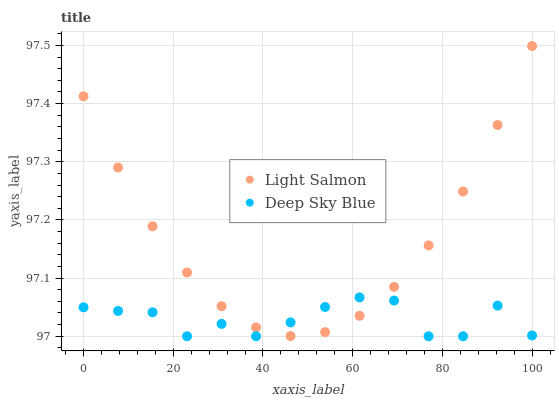Does Deep Sky Blue have the minimum area under the curve?
Answer yes or no. Yes. Does Light Salmon have the maximum area under the curve?
Answer yes or no. Yes. Does Deep Sky Blue have the maximum area under the curve?
Answer yes or no. No. Is Light Salmon the smoothest?
Answer yes or no. Yes. Is Deep Sky Blue the roughest?
Answer yes or no. Yes. Is Deep Sky Blue the smoothest?
Answer yes or no. No. Does Deep Sky Blue have the lowest value?
Answer yes or no. Yes. Does Light Salmon have the highest value?
Answer yes or no. Yes. Does Deep Sky Blue have the highest value?
Answer yes or no. No. Does Light Salmon intersect Deep Sky Blue?
Answer yes or no. Yes. Is Light Salmon less than Deep Sky Blue?
Answer yes or no. No. Is Light Salmon greater than Deep Sky Blue?
Answer yes or no. No. 